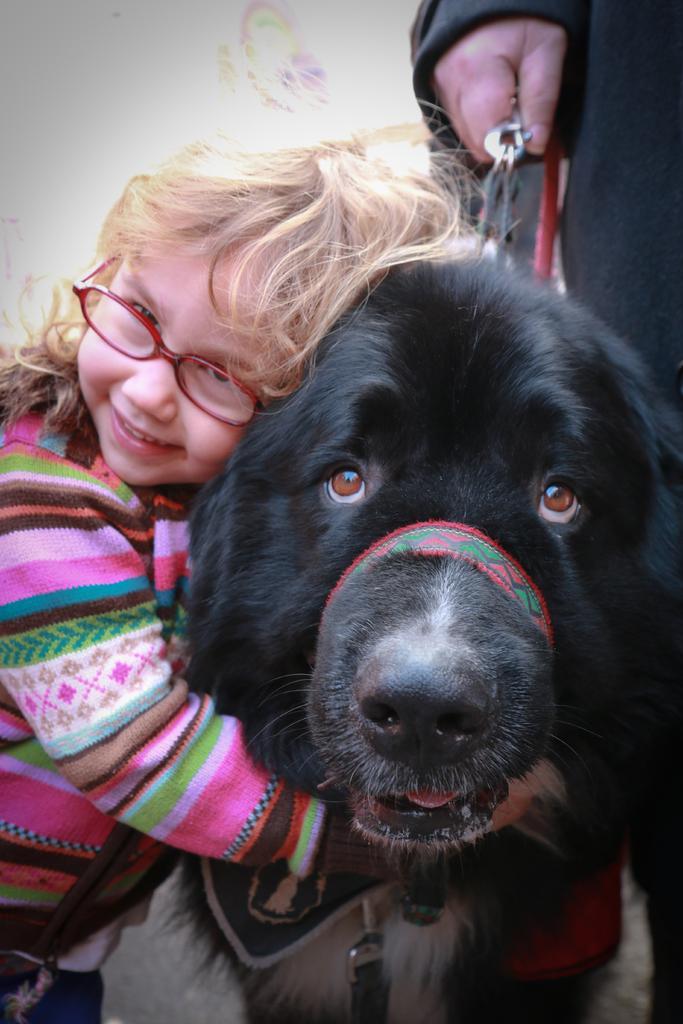Can you describe this image briefly? in this picture we can see a baby standing by catching a dog beside her we can see a person holding a belt of the dog. 